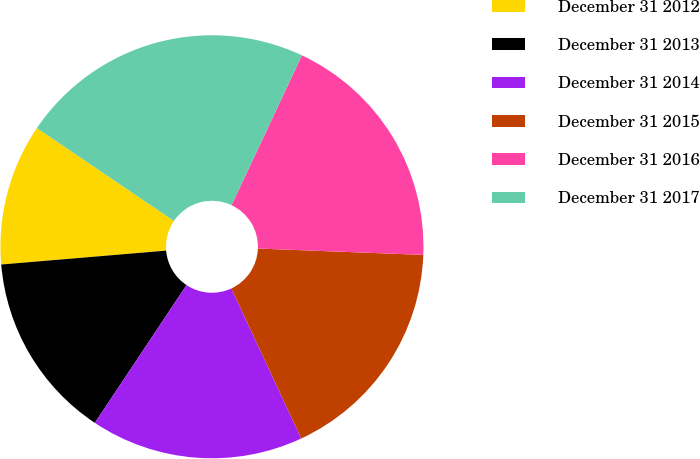Convert chart. <chart><loc_0><loc_0><loc_500><loc_500><pie_chart><fcel>December 31 2012<fcel>December 31 2013<fcel>December 31 2014<fcel>December 31 2015<fcel>December 31 2016<fcel>December 31 2017<nl><fcel>10.82%<fcel>14.32%<fcel>16.28%<fcel>17.45%<fcel>18.62%<fcel>22.51%<nl></chart> 